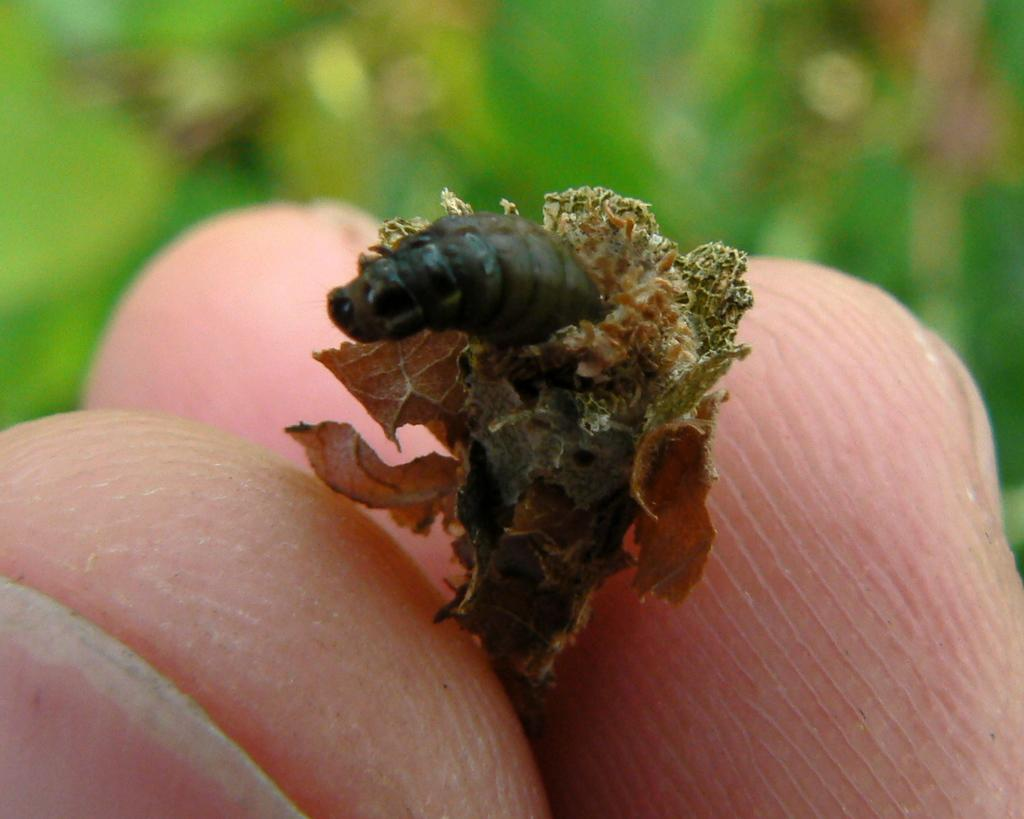What can be seen in the image that is related to the human body? There are fingers in the image. What type of natural objects are present in the image? There are dry leaves in the image. What living creature can be seen in the image? There is an insect in the image. How would you describe the background of the image? The background of the image is blurred. What type of food is being served in the image? There is no food present in the image; it features fingers, dry leaves, an insect, and a blurred background. What sound can be heard coming from the insect in the image? The image does not include any sounds, so it is not possible to determine what sound the insect might be making. 